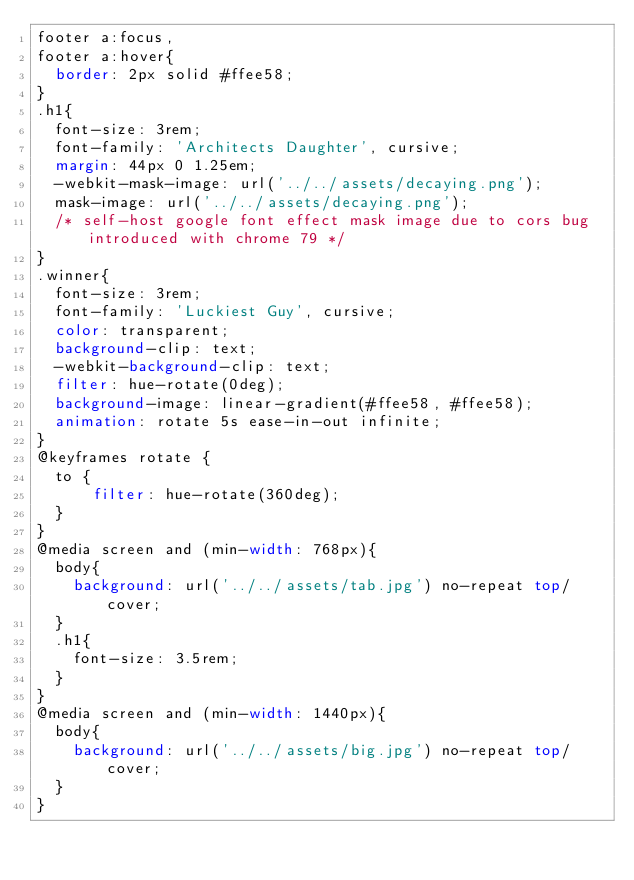Convert code to text. <code><loc_0><loc_0><loc_500><loc_500><_CSS_>footer a:focus,
footer a:hover{
  border: 2px solid #ffee58;
}
.h1{
  font-size: 3rem;
  font-family: 'Architects Daughter', cursive;
  margin: 44px 0 1.25em;
  -webkit-mask-image: url('../../assets/decaying.png');
  mask-image: url('../../assets/decaying.png');
  /* self-host google font effect mask image due to cors bug introduced with chrome 79 */
}
.winner{
  font-size: 3rem;
  font-family: 'Luckiest Guy', cursive;
  color: transparent;
  background-clip: text;
  -webkit-background-clip: text;
  filter: hue-rotate(0deg);
  background-image: linear-gradient(#ffee58, #ffee58);
  animation: rotate 5s ease-in-out infinite;
}
@keyframes rotate {
  to {
      filter: hue-rotate(360deg);
  }
}
@media screen and (min-width: 768px){
  body{
    background: url('../../assets/tab.jpg') no-repeat top/cover;
  }
  .h1{
    font-size: 3.5rem;
  }
}
@media screen and (min-width: 1440px){
  body{
    background: url('../../assets/big.jpg') no-repeat top/cover;
  }
}</code> 